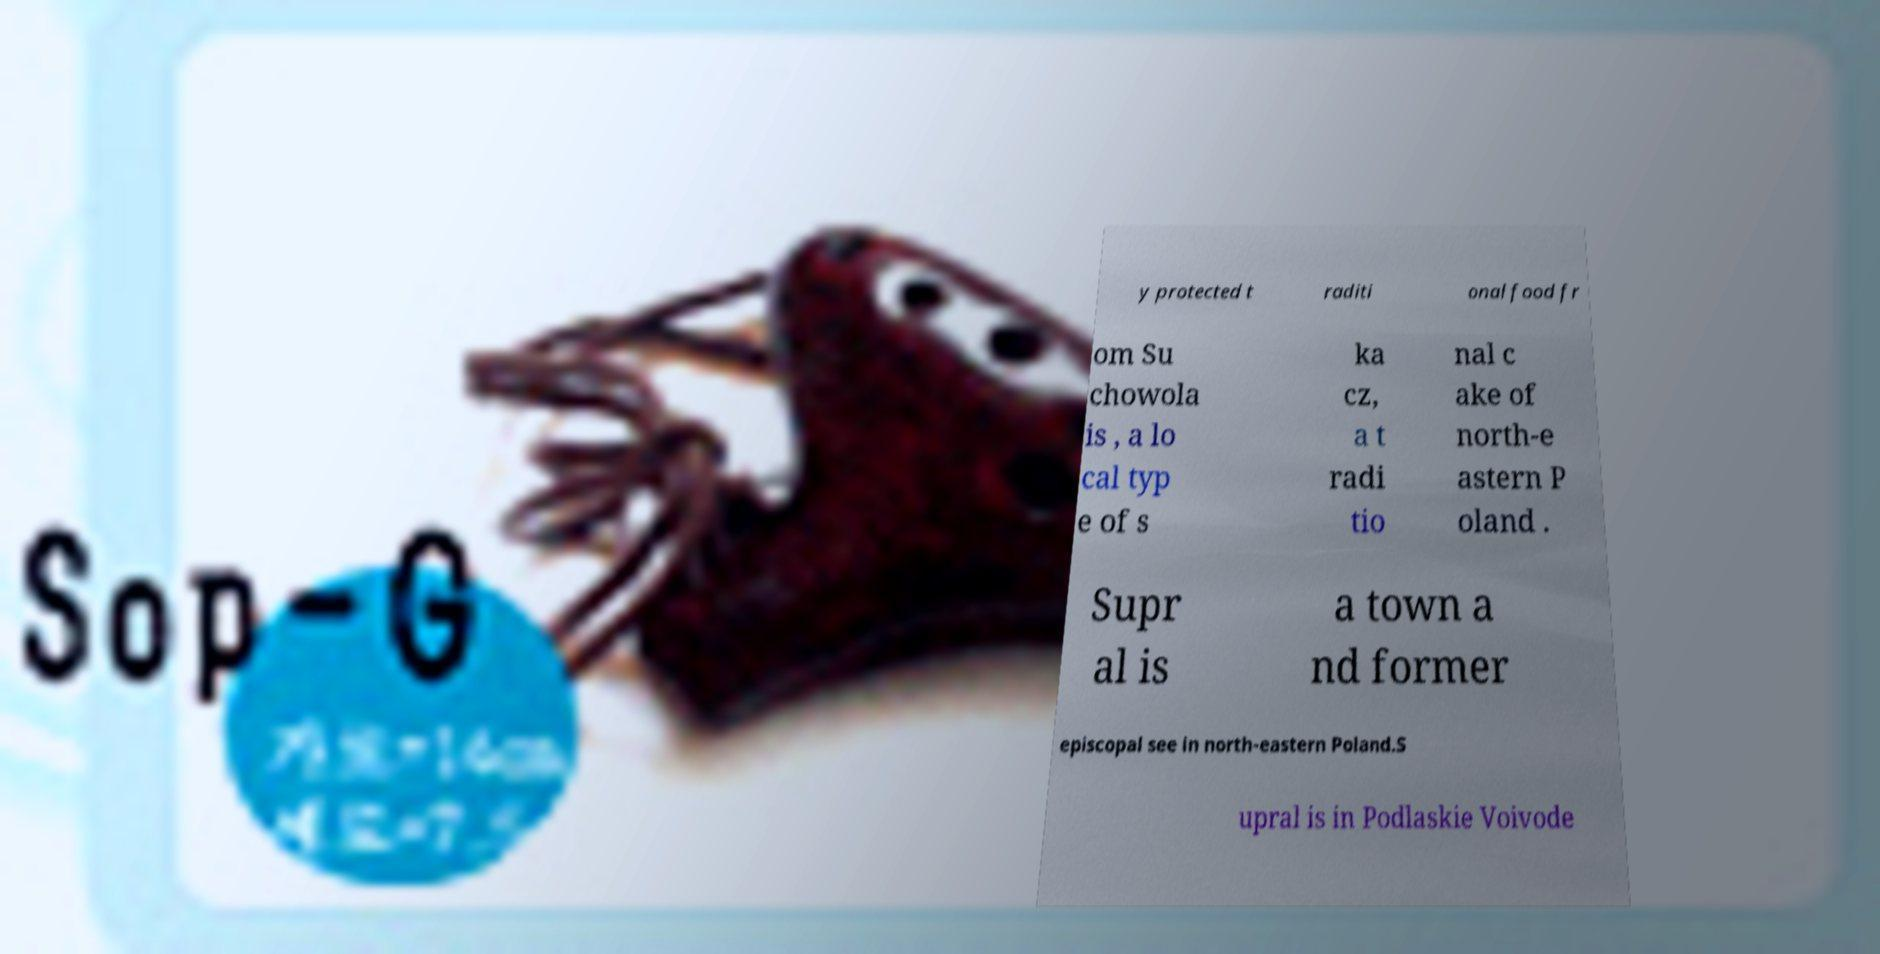Could you extract and type out the text from this image? y protected t raditi onal food fr om Su chowola is , a lo cal typ e of s ka cz, a t radi tio nal c ake of north-e astern P oland . Supr al is a town a nd former episcopal see in north-eastern Poland.S upral is in Podlaskie Voivode 